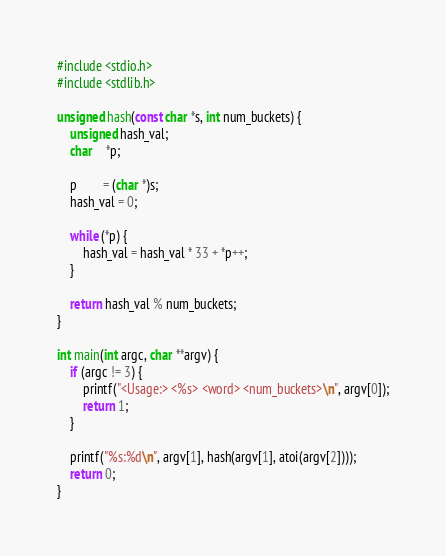<code> <loc_0><loc_0><loc_500><loc_500><_C_>#include <stdio.h>
#include <stdlib.h>

unsigned hash(const char *s, int num_buckets) {
    unsigned hash_val;
    char    *p;

    p        = (char *)s;
    hash_val = 0;

    while (*p) {
        hash_val = hash_val * 33 + *p++;
    }

    return hash_val % num_buckets;
}

int main(int argc, char **argv) {
    if (argc != 3) {
        printf("<Usage:> <%s> <word> <num_buckets>\n", argv[0]);
        return 1;
    }

    printf("%s:%d\n", argv[1], hash(argv[1], atoi(argv[2])));
    return 0;
}
</code> 